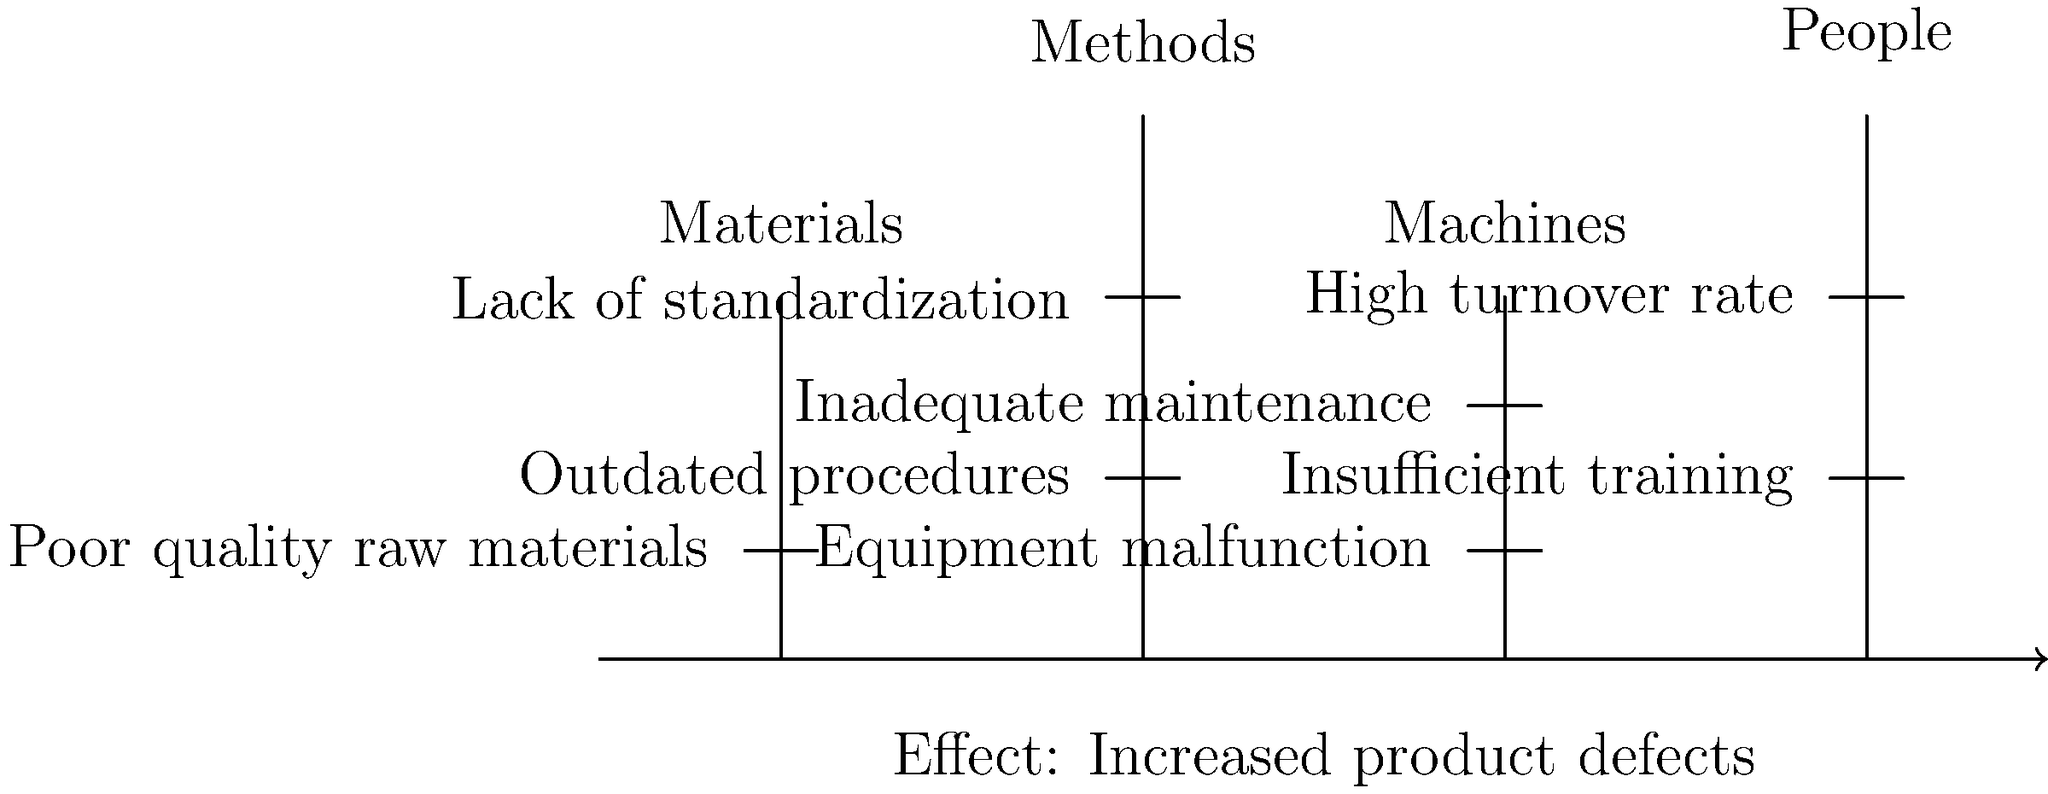Based on the fishbone diagram provided, which category appears to have the most potential root causes contributing to the increased product defects? To determine which category has the most potential root causes contributing to the increased product defects, we need to analyze each category in the fishbone diagram:

1. Materials:
   - Only one cause listed: Poor quality raw materials

2. Methods:
   - Two causes listed: Outdated procedures and Lack of standardization

3. Machines:
   - Two causes listed: Equipment malfunction and Inadequate maintenance

4. People:
   - Two causes listed: Insufficient training and High turnover rate

By counting the number of causes listed under each category, we can see that Methods, Machines, and People all have two causes listed, while Materials only has one.

However, the question asks for the category with the most "potential" root causes. Given that Methods deals with processes and procedures, it has the broadest scope for improvement and can potentially address multiple issues within the production process. Updating procedures and implementing standardization can have far-reaching effects on product quality.

Therefore, while three categories have the same number of listed causes, Methods appears to have the most potential for addressing root causes of increased product defects.
Answer: Methods 